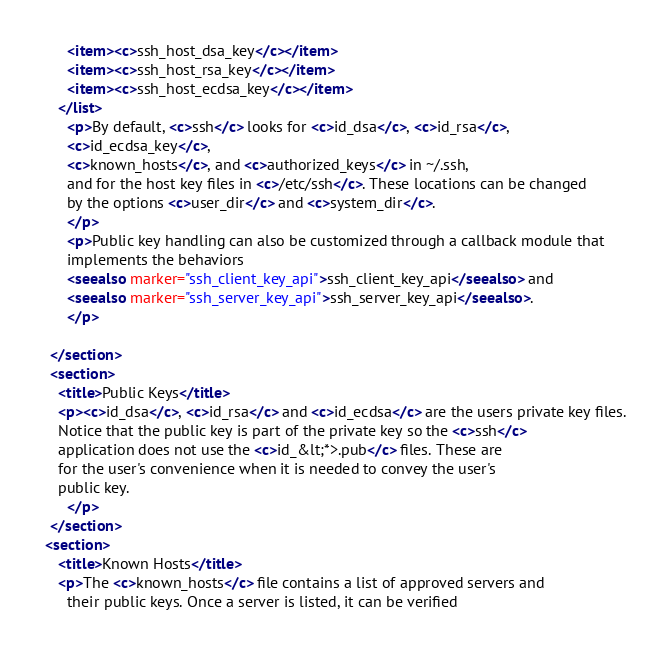Convert code to text. <code><loc_0><loc_0><loc_500><loc_500><_XML_>      <item><c>ssh_host_dsa_key</c></item>
      <item><c>ssh_host_rsa_key</c></item>
      <item><c>ssh_host_ecdsa_key</c></item>
    </list>
      <p>By default, <c>ssh</c> looks for <c>id_dsa</c>, <c>id_rsa</c>,
      <c>id_ecdsa_key</c>,
      <c>known_hosts</c>, and <c>authorized_keys</c> in ~/.ssh,
      and for the host key files in <c>/etc/ssh</c>. These locations can be changed
      by the options <c>user_dir</c> and <c>system_dir</c>.
      </p>
      <p>Public key handling can also be customized through a callback module that
      implements the behaviors
      <seealso marker="ssh_client_key_api">ssh_client_key_api</seealso> and
      <seealso marker="ssh_server_key_api">ssh_server_key_api</seealso>.
      </p>

  </section>
  <section>
    <title>Public Keys</title>
    <p><c>id_dsa</c>, <c>id_rsa</c> and <c>id_ecdsa</c> are the users private key files.
	Notice that the public key is part of the private key so the <c>ssh</c>
	application does not use the <c>id_&lt;*>.pub</c> files. These are
	for the user's convenience when it is needed to convey the user's
	public key.
      </p>
  </section>
 <section>
    <title>Known Hosts</title>
    <p>The <c>known_hosts</c> file contains a list of approved servers and
      their public keys. Once a server is listed, it can be verified</code> 